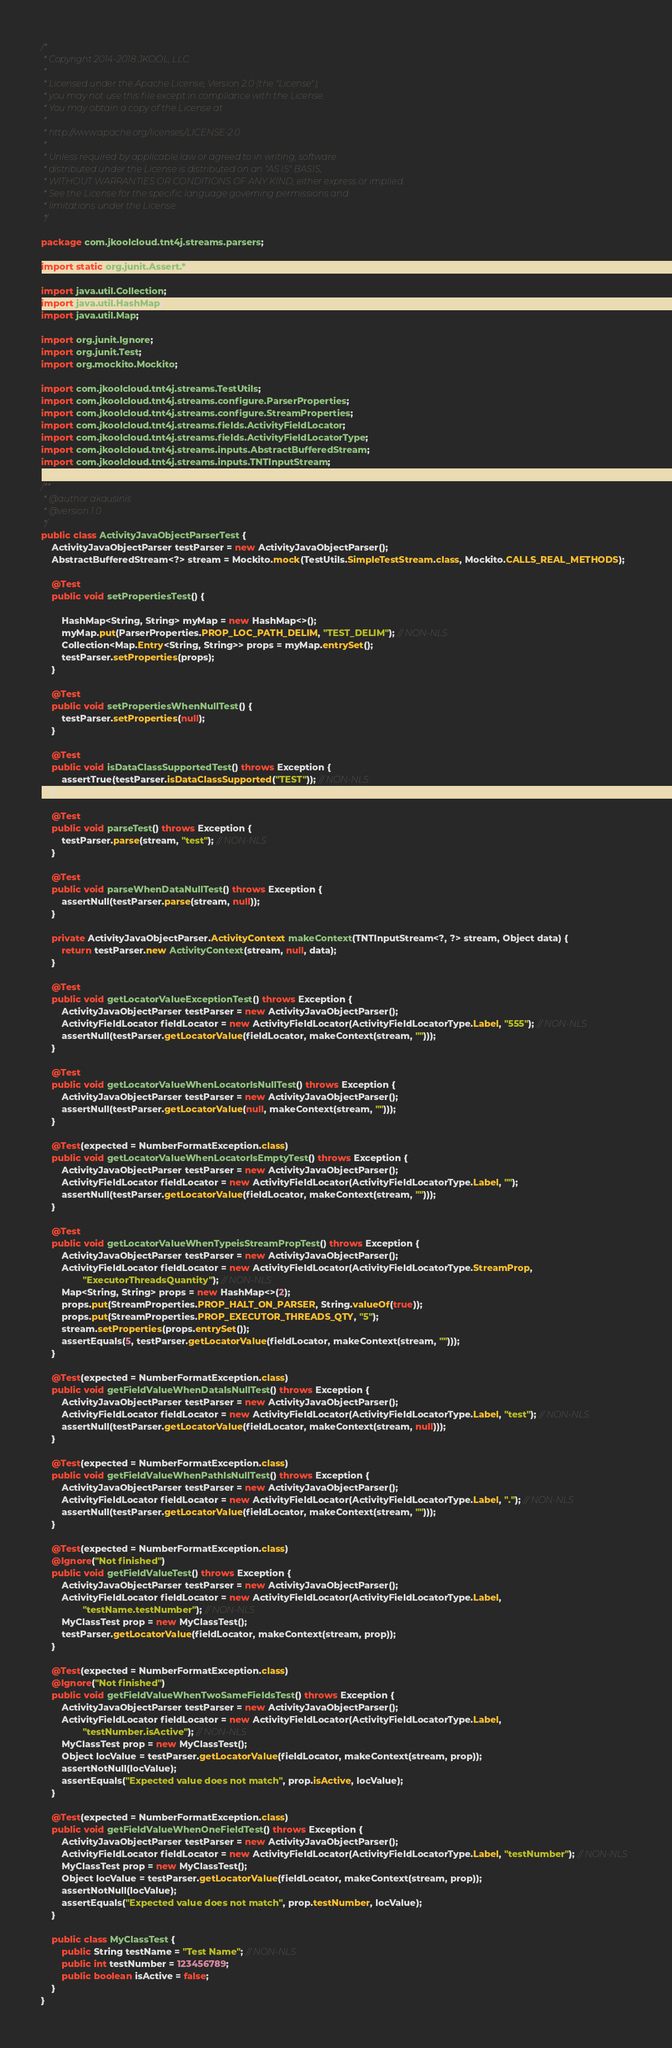Convert code to text. <code><loc_0><loc_0><loc_500><loc_500><_Java_>/*
 * Copyright 2014-2018 JKOOL, LLC.
 *
 * Licensed under the Apache License, Version 2.0 (the "License");
 * you may not use this file except in compliance with the License.
 * You may obtain a copy of the License at
 *
 * http://www.apache.org/licenses/LICENSE-2.0
 *
 * Unless required by applicable law or agreed to in writing, software
 * distributed under the License is distributed on an "AS IS" BASIS,
 * WITHOUT WARRANTIES OR CONDITIONS OF ANY KIND, either express or implied.
 * See the License for the specific language governing permissions and
 * limitations under the License.
 */

package com.jkoolcloud.tnt4j.streams.parsers;

import static org.junit.Assert.*;

import java.util.Collection;
import java.util.HashMap;
import java.util.Map;

import org.junit.Ignore;
import org.junit.Test;
import org.mockito.Mockito;

import com.jkoolcloud.tnt4j.streams.TestUtils;
import com.jkoolcloud.tnt4j.streams.configure.ParserProperties;
import com.jkoolcloud.tnt4j.streams.configure.StreamProperties;
import com.jkoolcloud.tnt4j.streams.fields.ActivityFieldLocator;
import com.jkoolcloud.tnt4j.streams.fields.ActivityFieldLocatorType;
import com.jkoolcloud.tnt4j.streams.inputs.AbstractBufferedStream;
import com.jkoolcloud.tnt4j.streams.inputs.TNTInputStream;

/**
 * @author akausinis
 * @version 1.0
 */
public class ActivityJavaObjectParserTest {
	ActivityJavaObjectParser testParser = new ActivityJavaObjectParser();
	AbstractBufferedStream<?> stream = Mockito.mock(TestUtils.SimpleTestStream.class, Mockito.CALLS_REAL_METHODS);

	@Test
	public void setPropertiesTest() {

		HashMap<String, String> myMap = new HashMap<>();
		myMap.put(ParserProperties.PROP_LOC_PATH_DELIM, "TEST_DELIM"); // NON-NLS
		Collection<Map.Entry<String, String>> props = myMap.entrySet();
		testParser.setProperties(props);
	}

	@Test
	public void setPropertiesWhenNullTest() {
		testParser.setProperties(null);
	}

	@Test
	public void isDataClassSupportedTest() throws Exception {
		assertTrue(testParser.isDataClassSupported("TEST")); // NON-NLS
	}

	@Test
	public void parseTest() throws Exception {
		testParser.parse(stream, "test"); // NON-NLS
	}

	@Test
	public void parseWhenDataNullTest() throws Exception {
		assertNull(testParser.parse(stream, null));
	}

	private ActivityJavaObjectParser.ActivityContext makeContext(TNTInputStream<?, ?> stream, Object data) {
		return testParser.new ActivityContext(stream, null, data);
	}

	@Test
	public void getLocatorValueExceptionTest() throws Exception {
		ActivityJavaObjectParser testParser = new ActivityJavaObjectParser();
		ActivityFieldLocator fieldLocator = new ActivityFieldLocator(ActivityFieldLocatorType.Label, "555"); // NON-NLS
		assertNull(testParser.getLocatorValue(fieldLocator, makeContext(stream, "")));
	}

	@Test
	public void getLocatorValueWhenLocatorIsNullTest() throws Exception {
		ActivityJavaObjectParser testParser = new ActivityJavaObjectParser();
		assertNull(testParser.getLocatorValue(null, makeContext(stream, "")));
	}

	@Test(expected = NumberFormatException.class)
	public void getLocatorValueWhenLocatorIsEmptyTest() throws Exception {
		ActivityJavaObjectParser testParser = new ActivityJavaObjectParser();
		ActivityFieldLocator fieldLocator = new ActivityFieldLocator(ActivityFieldLocatorType.Label, "");
		assertNull(testParser.getLocatorValue(fieldLocator, makeContext(stream, "")));
	}

	@Test
	public void getLocatorValueWhenTypeisStreamPropTest() throws Exception {
		ActivityJavaObjectParser testParser = new ActivityJavaObjectParser();
		ActivityFieldLocator fieldLocator = new ActivityFieldLocator(ActivityFieldLocatorType.StreamProp,
				"ExecutorThreadsQuantity"); // NON-NLS
		Map<String, String> props = new HashMap<>(2);
		props.put(StreamProperties.PROP_HALT_ON_PARSER, String.valueOf(true));
		props.put(StreamProperties.PROP_EXECUTOR_THREADS_QTY, "5");
		stream.setProperties(props.entrySet());
		assertEquals(5, testParser.getLocatorValue(fieldLocator, makeContext(stream, "")));
	}

	@Test(expected = NumberFormatException.class)
	public void getFieldValueWhenDataIsNullTest() throws Exception {
		ActivityJavaObjectParser testParser = new ActivityJavaObjectParser();
		ActivityFieldLocator fieldLocator = new ActivityFieldLocator(ActivityFieldLocatorType.Label, "test"); // NON-NLS
		assertNull(testParser.getLocatorValue(fieldLocator, makeContext(stream, null)));
	}

	@Test(expected = NumberFormatException.class)
	public void getFieldValueWhenPathIsNullTest() throws Exception {
		ActivityJavaObjectParser testParser = new ActivityJavaObjectParser();
		ActivityFieldLocator fieldLocator = new ActivityFieldLocator(ActivityFieldLocatorType.Label, "."); // NON-NLS
		assertNull(testParser.getLocatorValue(fieldLocator, makeContext(stream, "")));
	}

	@Test(expected = NumberFormatException.class)
	@Ignore("Not finished")
	public void getFieldValueTest() throws Exception {
		ActivityJavaObjectParser testParser = new ActivityJavaObjectParser();
		ActivityFieldLocator fieldLocator = new ActivityFieldLocator(ActivityFieldLocatorType.Label,
				"testName.testNumber"); // NON-NLS
		MyClassTest prop = new MyClassTest();
		testParser.getLocatorValue(fieldLocator, makeContext(stream, prop));
	}

	@Test(expected = NumberFormatException.class)
	@Ignore("Not finished")
	public void getFieldValueWhenTwoSameFieldsTest() throws Exception {
		ActivityJavaObjectParser testParser = new ActivityJavaObjectParser();
		ActivityFieldLocator fieldLocator = new ActivityFieldLocator(ActivityFieldLocatorType.Label,
				"testNumber.isActive"); // NON-NLS
		MyClassTest prop = new MyClassTest();
		Object locValue = testParser.getLocatorValue(fieldLocator, makeContext(stream, prop));
		assertNotNull(locValue);
		assertEquals("Expected value does not match", prop.isActive, locValue);
	}

	@Test(expected = NumberFormatException.class)
	public void getFieldValueWhenOneFieldTest() throws Exception {
		ActivityJavaObjectParser testParser = new ActivityJavaObjectParser();
		ActivityFieldLocator fieldLocator = new ActivityFieldLocator(ActivityFieldLocatorType.Label, "testNumber"); // NON-NLS
		MyClassTest prop = new MyClassTest();
		Object locValue = testParser.getLocatorValue(fieldLocator, makeContext(stream, prop));
		assertNotNull(locValue);
		assertEquals("Expected value does not match", prop.testNumber, locValue);
	}

	public class MyClassTest {
		public String testName = "Test Name"; // NON-NLS
		public int testNumber = 123456789;
		public boolean isActive = false;
	}
}</code> 